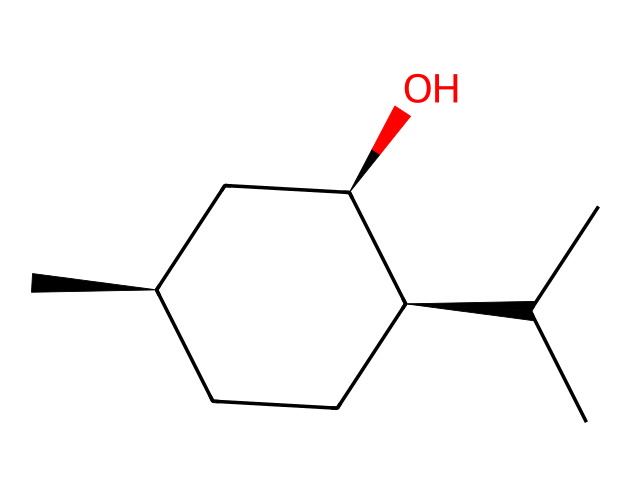What is the molecular formula of menthol? To determine the molecular formula, count the number of each type of atom based on the structure. The structure indicates there are 10 carbon (C) atoms, 20 hydrogen (H) atoms, and 1 oxygen (O) atom. Thus, the formula is C10H20O.
Answer: C10H20O How many chiral centers are in menthol? A chiral center is typically a carbon atom bonded to four different groups. Inspecting the structure reveals that there are three carbon atoms that are chiral centers, each being attached to different groups.
Answer: 3 What type of functional group is present in menthol? The presence of the hydroxyl group (-OH) indicates that menthol contains an alcohol functional group. This is further confirmed by the -OH group visible in the structure.
Answer: alcohol Which stereoisomer configuration is indicated by the SMILES notation? The '@' symbol in the SMILES notation indicates that the following chiral centers are specifically designated with stereochemistry (R or S). In this case, it shows that the configuration is given, resulting in two 'C@H', indicating specific three-dimensional arrangements.
Answer: R and S What is the main use of menthol in throat lozenges? Menthol is primarily used for its cooling sensation and soothing effect. It helps relieve throat irritation and provides a refreshing taste. This property makes it particularly effective in throat lozenges for vocalists.
Answer: soothing effect How does menthol's chirality affect its taste perception? The chirality of menthol allows it to interact differently with taste receptors. Its specific stereochemistry influences how it binds to receptors on the tongue, contributing to its unique cooling and minty flavor sensation.
Answer: unique taste perception 